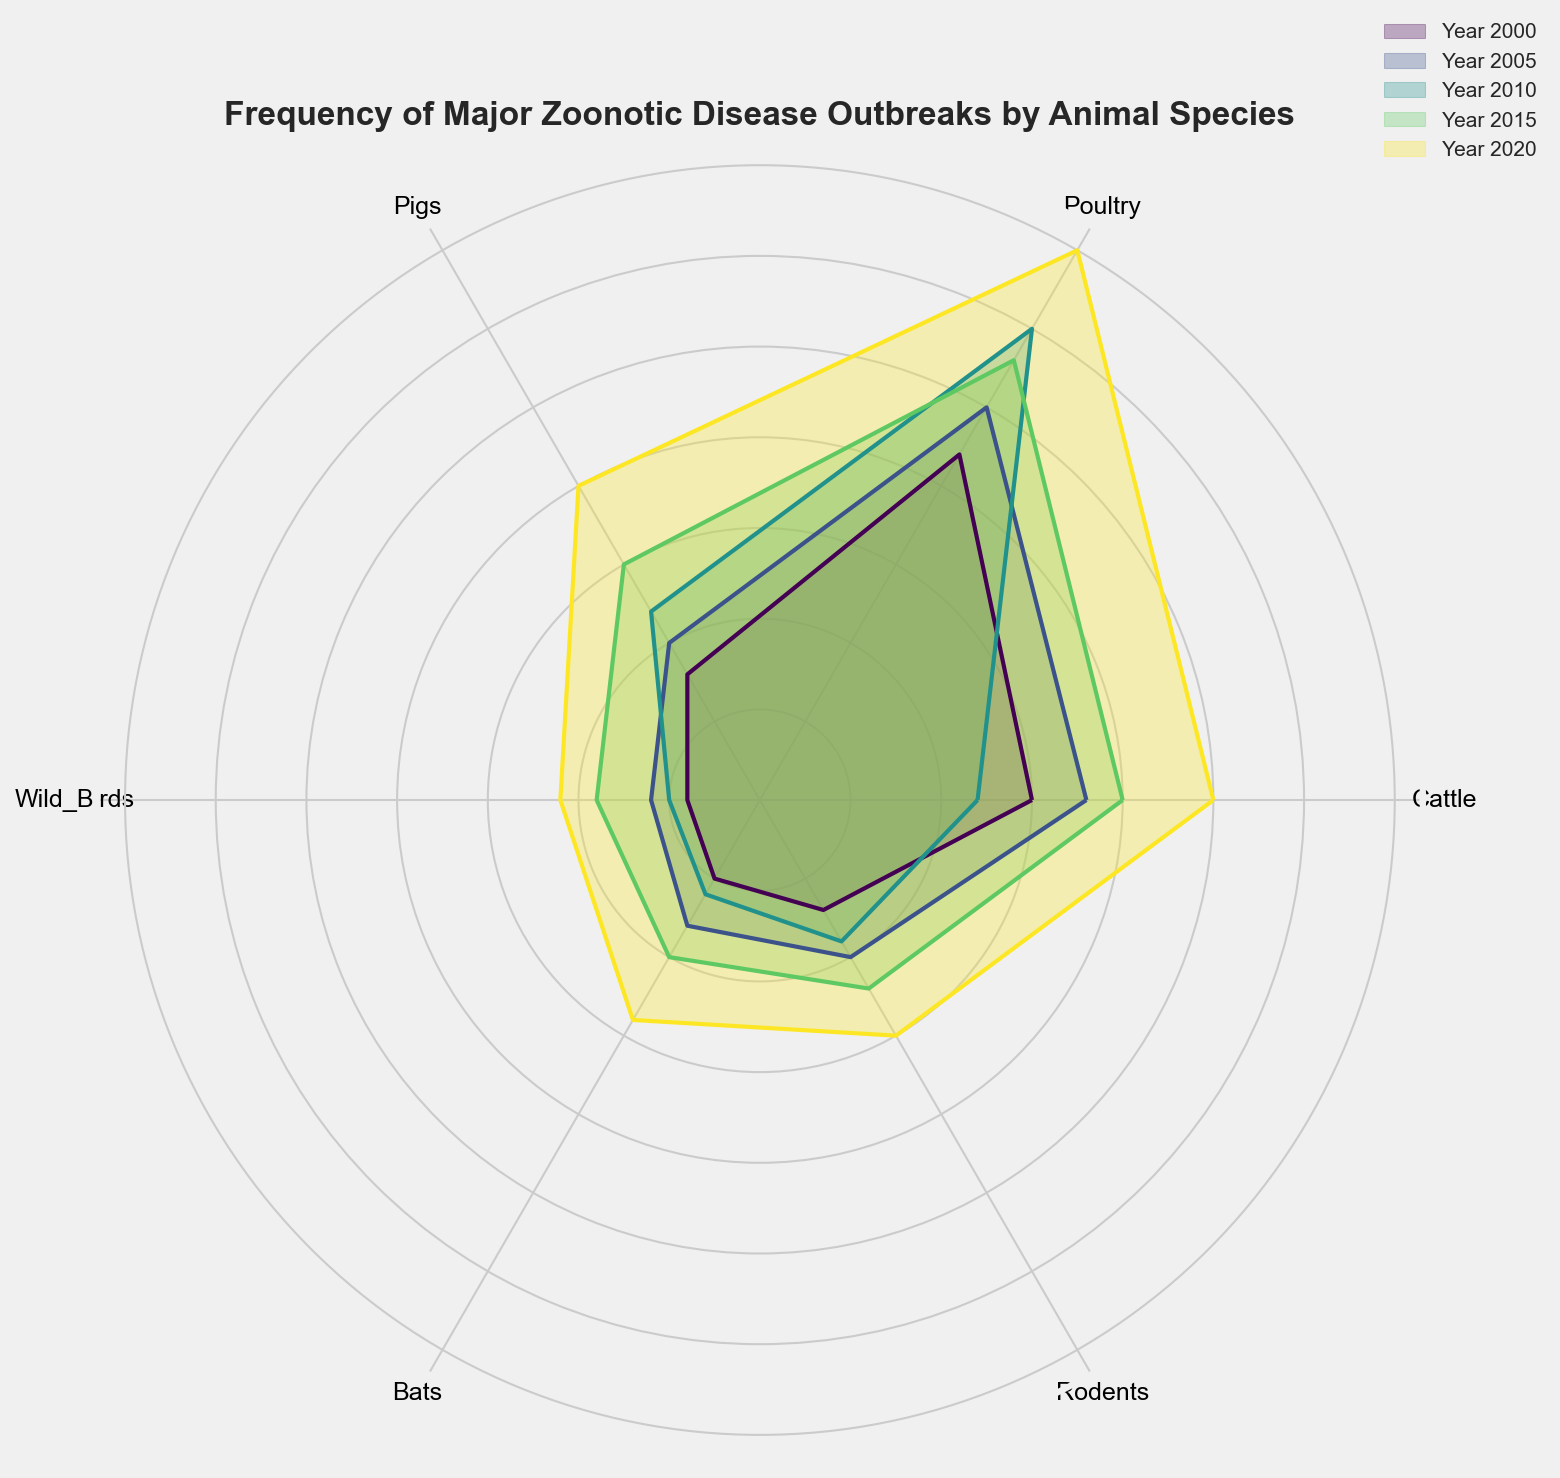What animal species had the highest frequency of outbreaks in 2020? The figure shows frequency by animal species and year, with Poultry having the largest radial section in 2020.
Answer: Poultry How did the frequency of rodent-related outbreaks change from 2000 to 2020? Observing the radial sections for Rodents in 2000 and 2020, we see that it increased from 7 in 2000 to 15 in 2020.
Answer: Increased Which year had the highest overall frequency of major zoonotic disease outbreaks across all species? By examining the overall size of the radial sections for each year, 2020 has the largest sections indicating the highest frequency.
Answer: 2020 Between which years did Wild Birds show the most significant increase in outbreak frequency? Comparing the radial sections for Wild Birds across the years, the biggest increase is from 2015 to 2020, rising from 9 to 11.
Answer: 2015 to 2020 What was the difference in outbreak frequency between Bats and Pigs in 2015? From the radial sections, in 2015, Bats had a frequency of 10 and Pigs had a frequency of 15. The difference is 15 - 10 = 5.
Answer: 5 Did any species have a decrease in outbreak frequency in 2010 compared to 2005? By comparing the radial sections, Cattle decreased from 18 in 2005 to 12 in 2010.
Answer: Yes, Cattle What is the average frequency of outbreaks for Poultry from 2000 to 2020? The frequencies for Poultry are 22, 25, 30, 28, and 35. Sum these (22 + 25 + 30 + 28 + 35 = 140) and divide by 5 for the average 140 / 5 = 28.
Answer: 28 Which species had the least increase in outbreak frequency from 2000 to 2020? The smallest changes are in Wild Birds, which increased from 4 in 2000 to 11 in 2020, an increase of 7.
Answer: Wild Birds Did the frequency of outbreaks in cattle ever surpass that of poultry in any given year? Observing the radial sections, Poultry always has a larger or equal frequency compared to Cattle for each year.
Answer: No What is the total frequency of zoonotic outbreaks for Bats across all years? Sum the frequencies for Bats: 5 (2000) + 8 (2005) + 6 (2010) + 10 (2015) + 14 (2020) = 43.
Answer: 43 